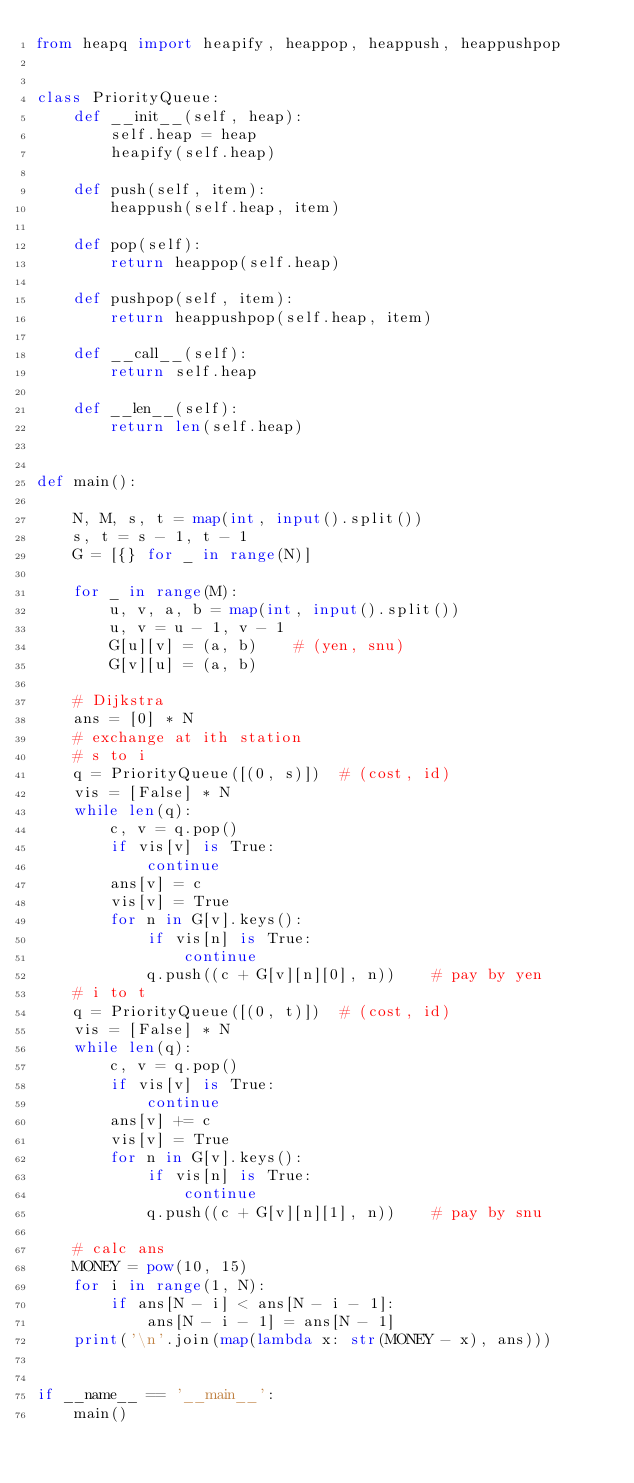<code> <loc_0><loc_0><loc_500><loc_500><_Python_>from heapq import heapify, heappop, heappush, heappushpop


class PriorityQueue:
    def __init__(self, heap):
        self.heap = heap
        heapify(self.heap)

    def push(self, item):
        heappush(self.heap, item)

    def pop(self):
        return heappop(self.heap)

    def pushpop(self, item):
        return heappushpop(self.heap, item)

    def __call__(self):
        return self.heap

    def __len__(self):
        return len(self.heap)


def main():

    N, M, s, t = map(int, input().split())
    s, t = s - 1, t - 1
    G = [{} for _ in range(N)]

    for _ in range(M):
        u, v, a, b = map(int, input().split())
        u, v = u - 1, v - 1
        G[u][v] = (a, b)    # (yen, snu)
        G[v][u] = (a, b)

    # Dijkstra
    ans = [0] * N
    # exchange at ith station
    # s to i
    q = PriorityQueue([(0, s)])  # (cost, id)
    vis = [False] * N
    while len(q):
        c, v = q.pop()
        if vis[v] is True:
            continue
        ans[v] = c
        vis[v] = True
        for n in G[v].keys():
            if vis[n] is True:
                continue
            q.push((c + G[v][n][0], n))    # pay by yen
    # i to t
    q = PriorityQueue([(0, t)])  # (cost, id)
    vis = [False] * N
    while len(q):
        c, v = q.pop()
        if vis[v] is True:
            continue
        ans[v] += c
        vis[v] = True
        for n in G[v].keys():
            if vis[n] is True:
                continue
            q.push((c + G[v][n][1], n))    # pay by snu

    # calc ans
    MONEY = pow(10, 15)
    for i in range(1, N):
        if ans[N - i] < ans[N - i - 1]:
            ans[N - i - 1] = ans[N - 1]
    print('\n'.join(map(lambda x: str(MONEY - x), ans)))


if __name__ == '__main__':
    main()
</code> 